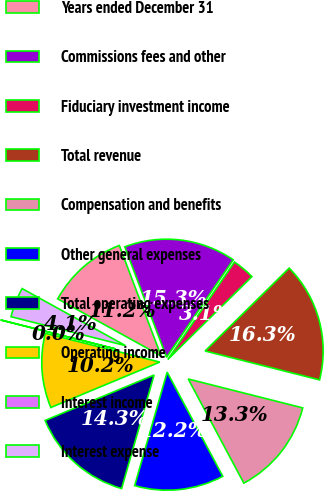Convert chart to OTSL. <chart><loc_0><loc_0><loc_500><loc_500><pie_chart><fcel>Years ended December 31<fcel>Commissions fees and other<fcel>Fiduciary investment income<fcel>Total revenue<fcel>Compensation and benefits<fcel>Other general expenses<fcel>Total operating expenses<fcel>Operating income<fcel>Interest income<fcel>Interest expense<nl><fcel>11.22%<fcel>15.3%<fcel>3.07%<fcel>16.32%<fcel>13.26%<fcel>12.24%<fcel>14.28%<fcel>10.2%<fcel>0.02%<fcel>4.09%<nl></chart> 